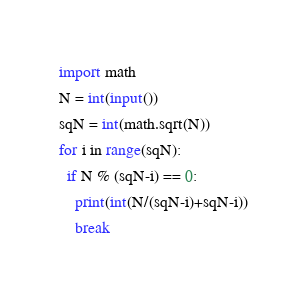<code> <loc_0><loc_0><loc_500><loc_500><_Python_>import math
N = int(input())
sqN = int(math.sqrt(N))
for i in range(sqN):
  if N % (sqN-i) == 0:
    print(int(N/(sqN-i)+sqN-i))
    break</code> 